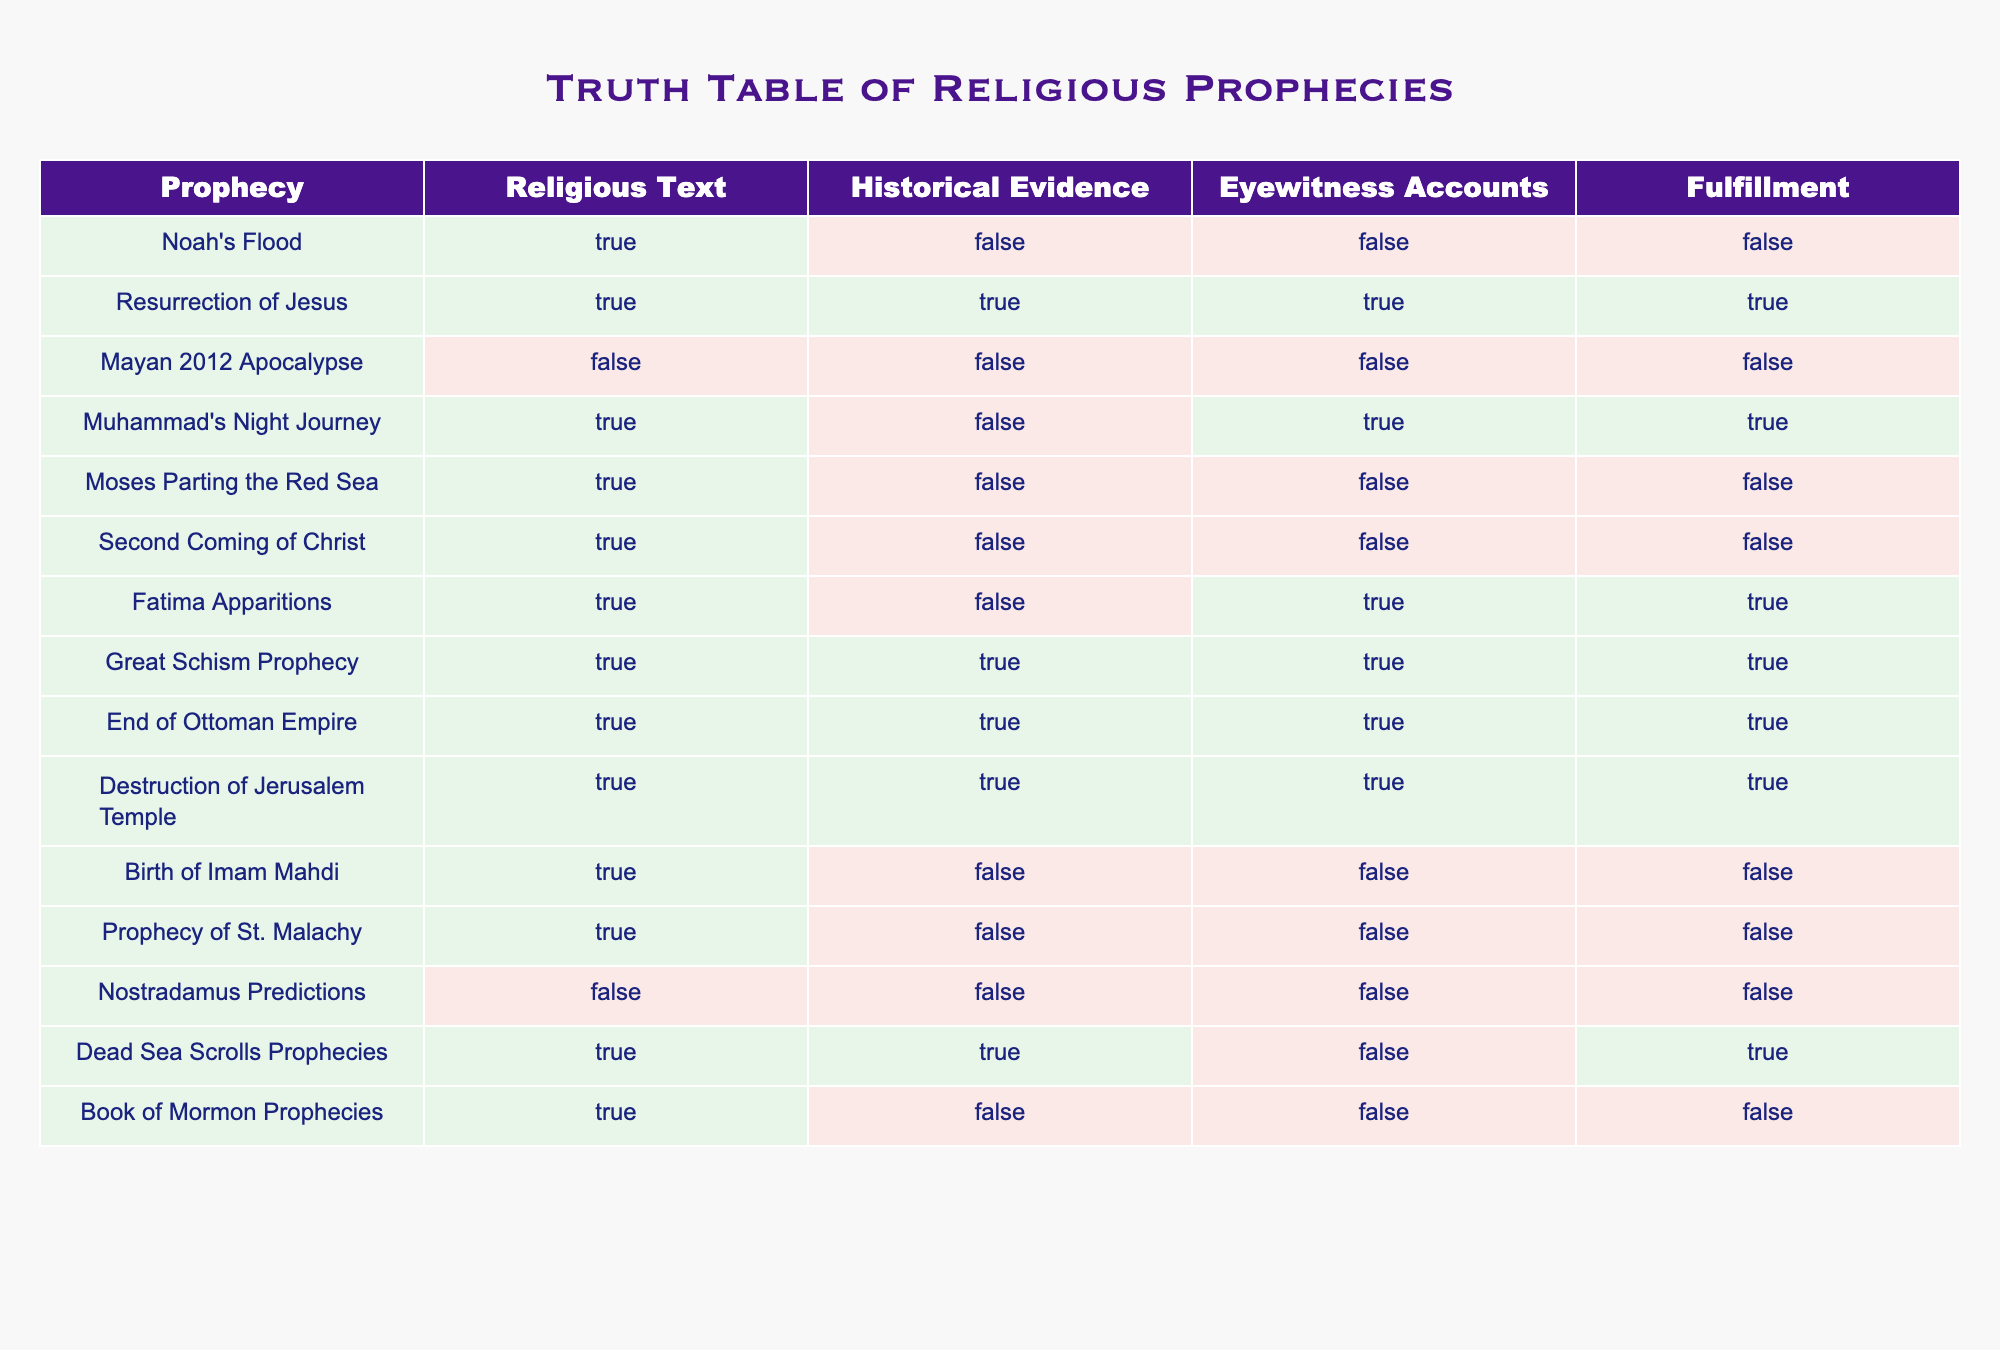What is the fulfillment status of Noah's Flood prophecy? The table indicates that Noah's Flood has a fulfillment value of False. Therefore, the prophecy was not fulfilled based on the recorded data.
Answer: False How many prophecies provide both historical evidence and eyewitness accounts? To determine this, I will check the table for entries where both "Historical Evidence" and "Eyewitness Accounts" are True. There are four such prophecies: Resurrection of Jesus, Great Schism Prophecy, End of Ottoman Empire, and Destruction of Jerusalem Temple.
Answer: 4 Is there any prophecy in the table that has true fulfillment but no historical evidence? Looking through the table, the prophecy "Muhammad's Night Journey" is true for fulfillment while having no historical evidence. Thus, it fits the criteria of having fulfillment True but historical evidence False.
Answer: Yes Which prophecy has true fulfillment and at least one true eyewitness account? The table shows that the "Resurrection of Jesus" has true fulfillment and also true eyewitness accounts. This is the only prophecy that fits both criteria as stated.
Answer: Resurrection of Jesus What is the total number of prophecies where the fulfillment is false? Counting the entries with "Fulfillment" marked as False, we see that there are five such prophecies: Noah's Flood, Mayan 2012 Apocalypse, Moses Parting the Red Sea, Birth of Imam Mahdi, and Book of Mormon Prophecies. Adding these gives a total of five prophecies with false fulfillment.
Answer: 5 Are there any prophecies that have true historical evidence but false eyewitness accounts? Examining the table reveals that "Great Schism Prophecy" and "End of Ottoman Empire" have true historical evidence, but there are no corresponding false eyewitness accounts for those entries. Hence, there are none that meet this specific condition.
Answer: No What is the relationship between historical evidence and fulfillment for the "Fatima Apparitions"? For "Fatima Apparitions," the column for historical evidence is False, but the fulfillment is True. Thus, there is a case where fulfillment is true despite the absence of historical evidence.
Answer: False historical evidence, True fulfillment Which prophecy has true fulfillment and does not have any eyewitness accounts? "Second Coming of Christ" is the prophecy with true fulfillment, and the eyewitness accounts column is marked as False. Therefore, it does fulfill the criteria of having true fulfillment without any eyewitness accounts.
Answer: Second Coming of Christ 